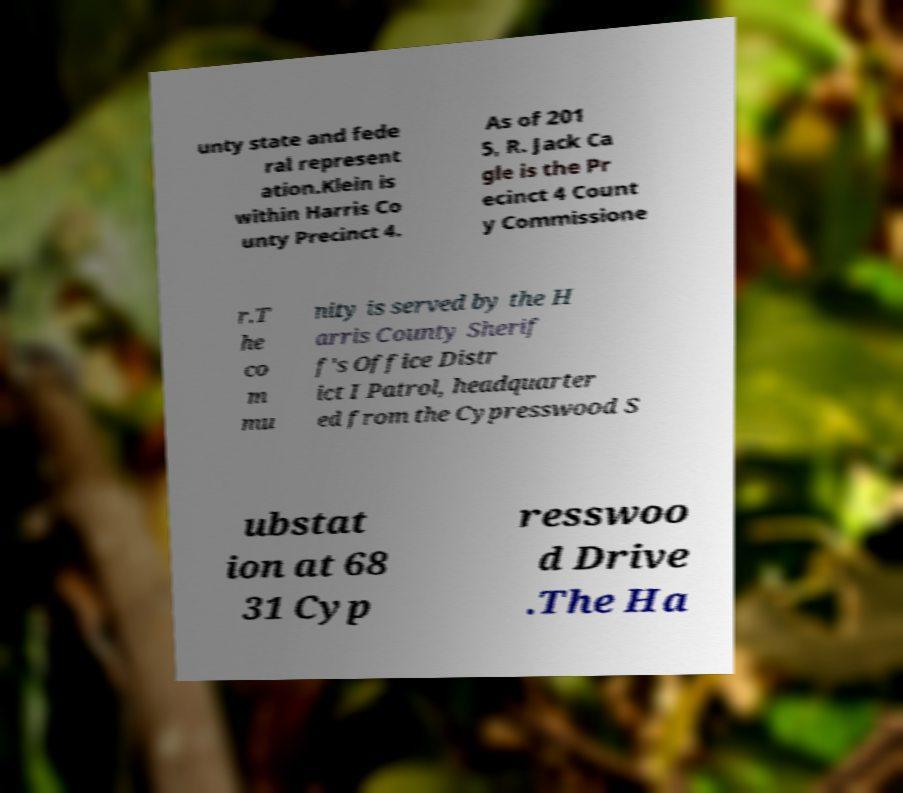There's text embedded in this image that I need extracted. Can you transcribe it verbatim? unty state and fede ral represent ation.Klein is within Harris Co unty Precinct 4. As of 201 5, R. Jack Ca gle is the Pr ecinct 4 Count y Commissione r.T he co m mu nity is served by the H arris County Sherif f's Office Distr ict I Patrol, headquarter ed from the Cypresswood S ubstat ion at 68 31 Cyp resswoo d Drive .The Ha 